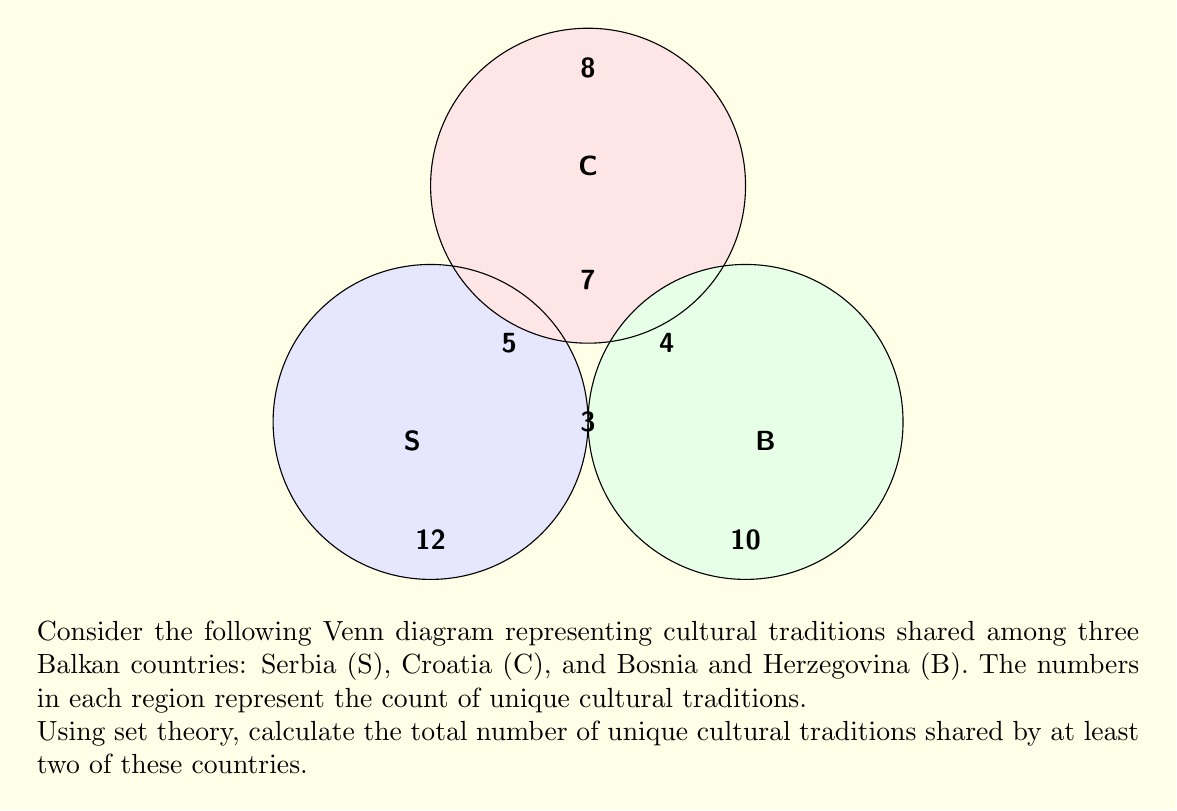Show me your answer to this math problem. Let's approach this step-by-step using set theory:

1) First, we need to identify the regions that represent traditions shared by at least two countries:

   - $|S \cap C| - |S \cap C \cap B| = 5 - 7 = -2$
   - $|S \cap B| - |S \cap C \cap B| = 3 - 7 = -4$
   - $|C \cap B| - |S \cap C \cap B| = 4 - 7 = -3$
   - $|S \cap C \cap B| = 7$

2) Now, we can use the Inclusion-Exclusion Principle to calculate the number of traditions shared by at least two countries:

   $|(S \cap C) \cup (S \cap B) \cup (C \cap B)| = |S \cap C| + |S \cap B| + |C \cap B| - 2|S \cap C \cap B|$

3) Substituting the values:

   $|(S \cap C) \cup (S \cap B) \cup (C \cap B)| = 5 + 3 + 4 - 2(7) = 12 - 14 = -2$

4) However, this result is negative, which doesn't make sense in the context of counting traditions. This is because we've double-counted the region $|S \cap C \cap B|$ in our calculation.

5) The correct calculation should be:

   $|(S \cap C) \cup (S \cap B) \cup (C \cap B)| = |S \cap C| + |S \cap B| + |C \cap B| - |S \cap C \cap B|$

6) Substituting the values:

   $|(S \cap C) \cup (S \cap B) \cup (C \cap B)| = 5 + 3 + 4 - 7 = 5$

Therefore, the total number of unique cultural traditions shared by at least two of these countries is 5.
Answer: 5 